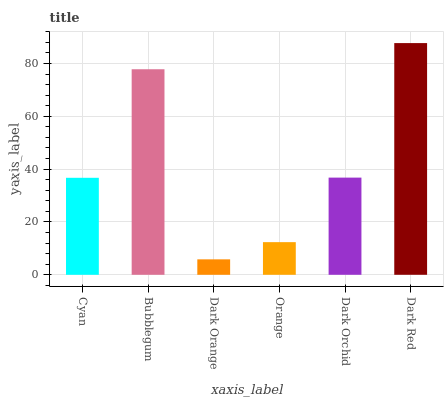Is Dark Orange the minimum?
Answer yes or no. Yes. Is Dark Red the maximum?
Answer yes or no. Yes. Is Bubblegum the minimum?
Answer yes or no. No. Is Bubblegum the maximum?
Answer yes or no. No. Is Bubblegum greater than Cyan?
Answer yes or no. Yes. Is Cyan less than Bubblegum?
Answer yes or no. Yes. Is Cyan greater than Bubblegum?
Answer yes or no. No. Is Bubblegum less than Cyan?
Answer yes or no. No. Is Dark Orchid the high median?
Answer yes or no. Yes. Is Cyan the low median?
Answer yes or no. Yes. Is Orange the high median?
Answer yes or no. No. Is Dark Orange the low median?
Answer yes or no. No. 